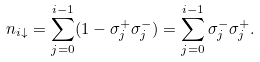Convert formula to latex. <formula><loc_0><loc_0><loc_500><loc_500>n _ { i \downarrow } = \sum _ { j = 0 } ^ { i - 1 } ( 1 - \sigma _ { j } ^ { + } \sigma _ { j } ^ { - } ) = \sum _ { j = 0 } ^ { i - 1 } \sigma _ { j } ^ { - } \sigma _ { j } ^ { + } .</formula> 